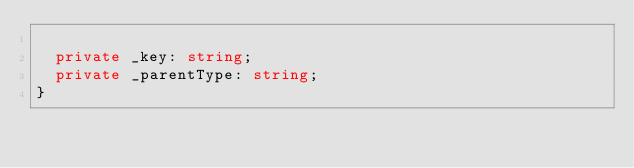<code> <loc_0><loc_0><loc_500><loc_500><_TypeScript_>
  private _key: string;
  private _parentType: string;
}
</code> 